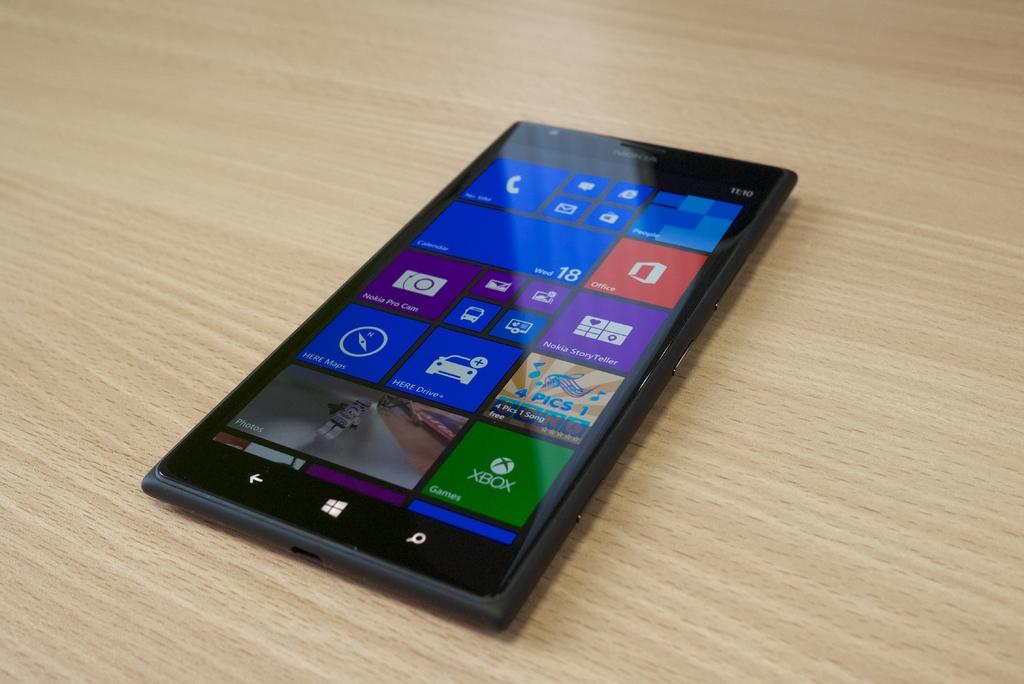<image>
Offer a succinct explanation of the picture presented. A cell phone laying on a table is turned on and the screen reveals several icons for apps like Xbox and Nokia Pro Cam. 